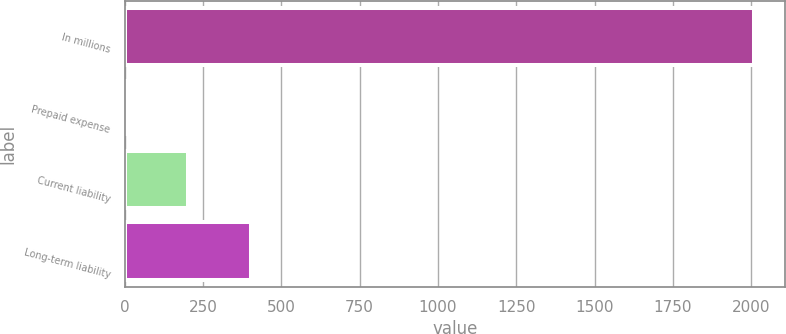<chart> <loc_0><loc_0><loc_500><loc_500><bar_chart><fcel>In millions<fcel>Prepaid expense<fcel>Current liability<fcel>Long-term liability<nl><fcel>2008<fcel>2.6<fcel>203.14<fcel>403.68<nl></chart> 